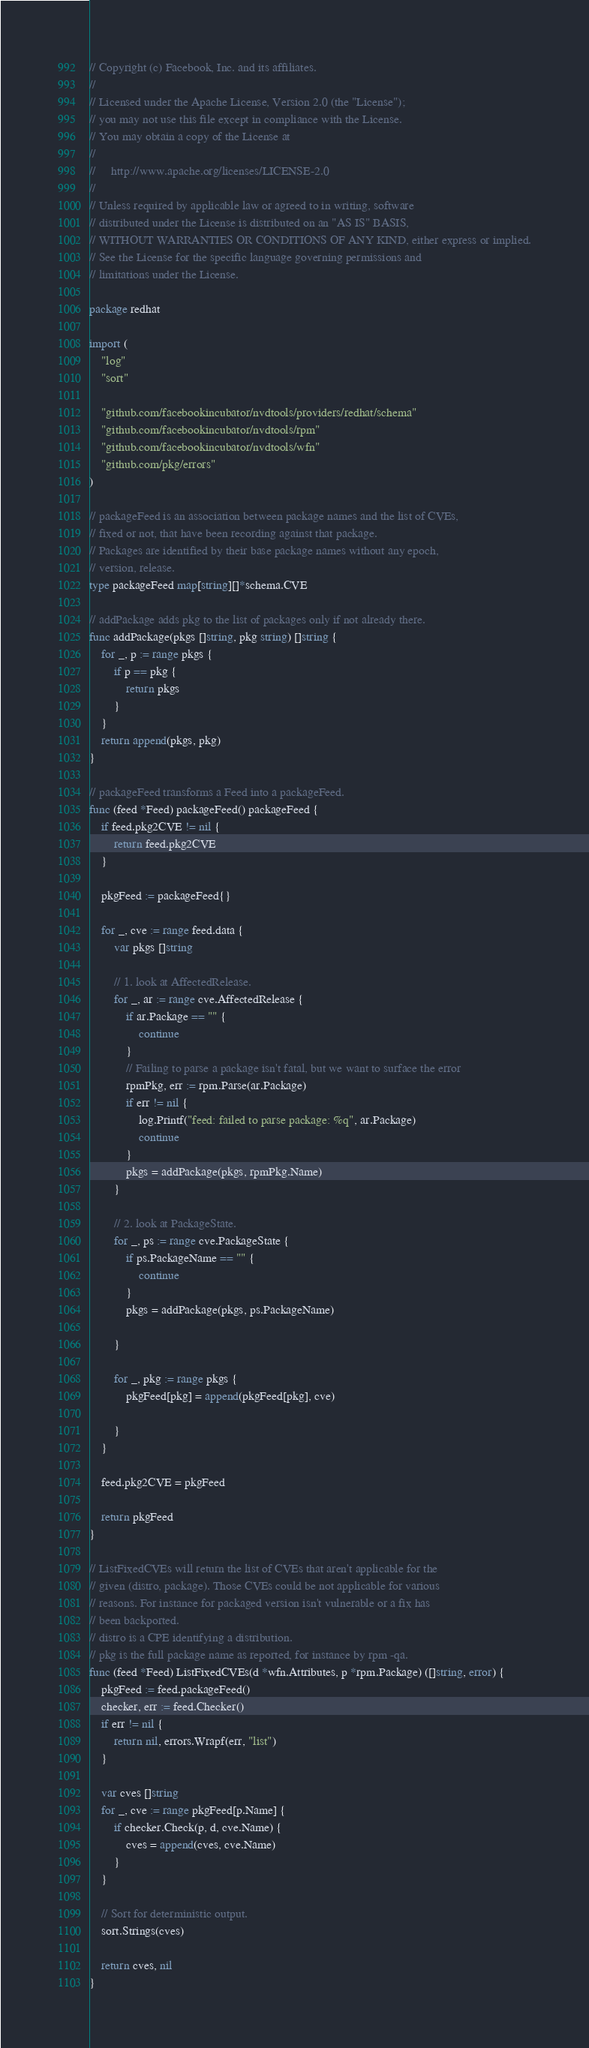Convert code to text. <code><loc_0><loc_0><loc_500><loc_500><_Go_>// Copyright (c) Facebook, Inc. and its affiliates.
//
// Licensed under the Apache License, Version 2.0 (the "License");
// you may not use this file except in compliance with the License.
// You may obtain a copy of the License at
//
//     http://www.apache.org/licenses/LICENSE-2.0
//
// Unless required by applicable law or agreed to in writing, software
// distributed under the License is distributed on an "AS IS" BASIS,
// WITHOUT WARRANTIES OR CONDITIONS OF ANY KIND, either express or implied.
// See the License for the specific language governing permissions and
// limitations under the License.

package redhat

import (
	"log"
	"sort"

	"github.com/facebookincubator/nvdtools/providers/redhat/schema"
	"github.com/facebookincubator/nvdtools/rpm"
	"github.com/facebookincubator/nvdtools/wfn"
	"github.com/pkg/errors"
)

// packageFeed is an association between package names and the list of CVEs,
// fixed or not, that have been recording against that package.
// Packages are identified by their base package names without any epoch,
// version, release.
type packageFeed map[string][]*schema.CVE

// addPackage adds pkg to the list of packages only if not already there.
func addPackage(pkgs []string, pkg string) []string {
	for _, p := range pkgs {
		if p == pkg {
			return pkgs
		}
	}
	return append(pkgs, pkg)
}

// packageFeed transforms a Feed into a packageFeed.
func (feed *Feed) packageFeed() packageFeed {
	if feed.pkg2CVE != nil {
		return feed.pkg2CVE
	}

	pkgFeed := packageFeed{}

	for _, cve := range feed.data {
		var pkgs []string

		// 1. look at AffectedRelease.
		for _, ar := range cve.AffectedRelease {
			if ar.Package == "" {
				continue
			}
			// Failing to parse a package isn't fatal, but we want to surface the error
			rpmPkg, err := rpm.Parse(ar.Package)
			if err != nil {
				log.Printf("feed: failed to parse package: %q", ar.Package)
				continue
			}
			pkgs = addPackage(pkgs, rpmPkg.Name)
		}

		// 2. look at PackageState.
		for _, ps := range cve.PackageState {
			if ps.PackageName == "" {
				continue
			}
			pkgs = addPackage(pkgs, ps.PackageName)

		}

		for _, pkg := range pkgs {
			pkgFeed[pkg] = append(pkgFeed[pkg], cve)

		}
	}

	feed.pkg2CVE = pkgFeed

	return pkgFeed
}

// ListFixedCVEs will return the list of CVEs that aren't applicable for the
// given (distro, package). Those CVEs could be not applicable for various
// reasons. For instance for packaged version isn't vulnerable or a fix has
// been backported.
// distro is a CPE identifying a distribution.
// pkg is the full package name as reported, for instance by rpm -qa.
func (feed *Feed) ListFixedCVEs(d *wfn.Attributes, p *rpm.Package) ([]string, error) {
	pkgFeed := feed.packageFeed()
	checker, err := feed.Checker()
	if err != nil {
		return nil, errors.Wrapf(err, "list")
	}

	var cves []string
	for _, cve := range pkgFeed[p.Name] {
		if checker.Check(p, d, cve.Name) {
			cves = append(cves, cve.Name)
		}
	}

	// Sort for deterministic output.
	sort.Strings(cves)

	return cves, nil
}
</code> 